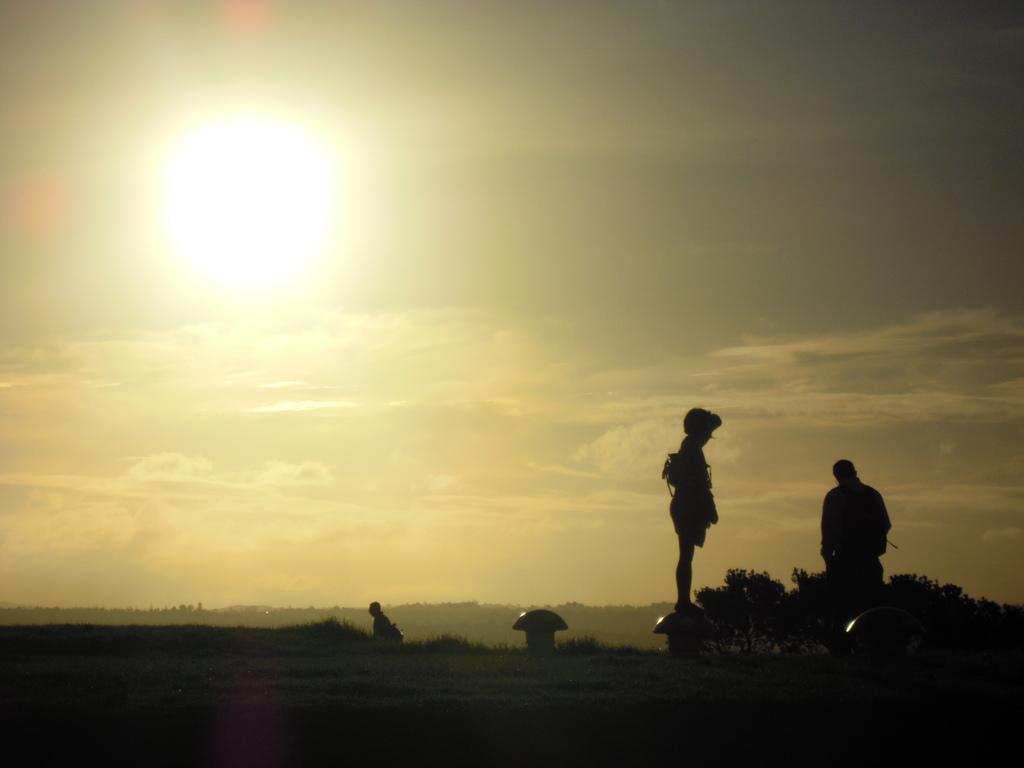Where was the image taken? The image is clicked outside. How many people are in the image? There are three persons in the image. What is at the bottom of the image? There is a ground at the bottom of the image. What can be seen in the sky in the background of the image? There are clouds and the sun visible in the sky in the background of the image. What type of guitar is being played by the person in jail in the image? There is no guitar or person in jail present in the image. 